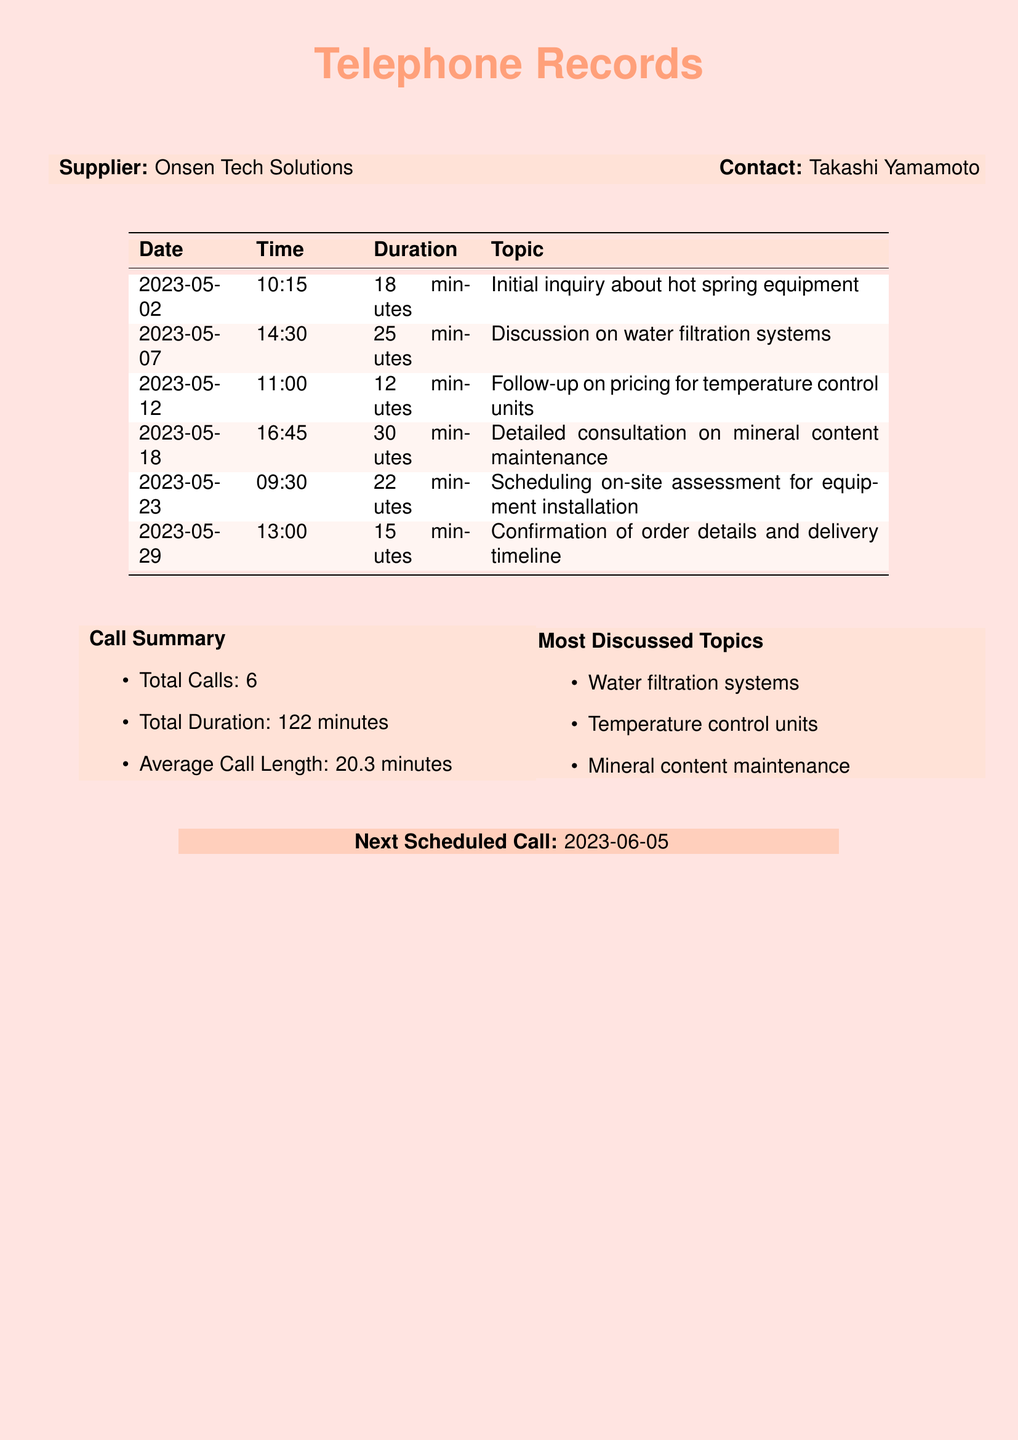what is the total number of calls made? The total number of calls made is provided in the call summary section of the document.
Answer: 6 what is the average call length? The average call length is calculated based on the total duration divided by the number of calls, as stated in the call summary section.
Answer: 20.3 minutes who is the contact person at Onsen Tech Solutions? The contact person is indicated at the beginning of the document.
Answer: Takashi Yamamoto what was discussed on 2023-05-18? The detailed consultation topic for that date is mentioned in the table of conversations.
Answer: Mineral content maintenance how many minutes did the longest call last? The longest call can be identified from the duration listed in the table.
Answer: 30 minutes what is the next scheduled call date? The next scheduled call is mentioned in the concluding section of the document.
Answer: 2023-06-05 what was the date of the initial inquiry? The date of the initial inquiry is the first entry in the call records.
Answer: 2023-05-02 how many minutes were spent discussing water filtration systems? The duration for the discussion of water filtration systems can be found in the table.
Answer: 25 minutes 